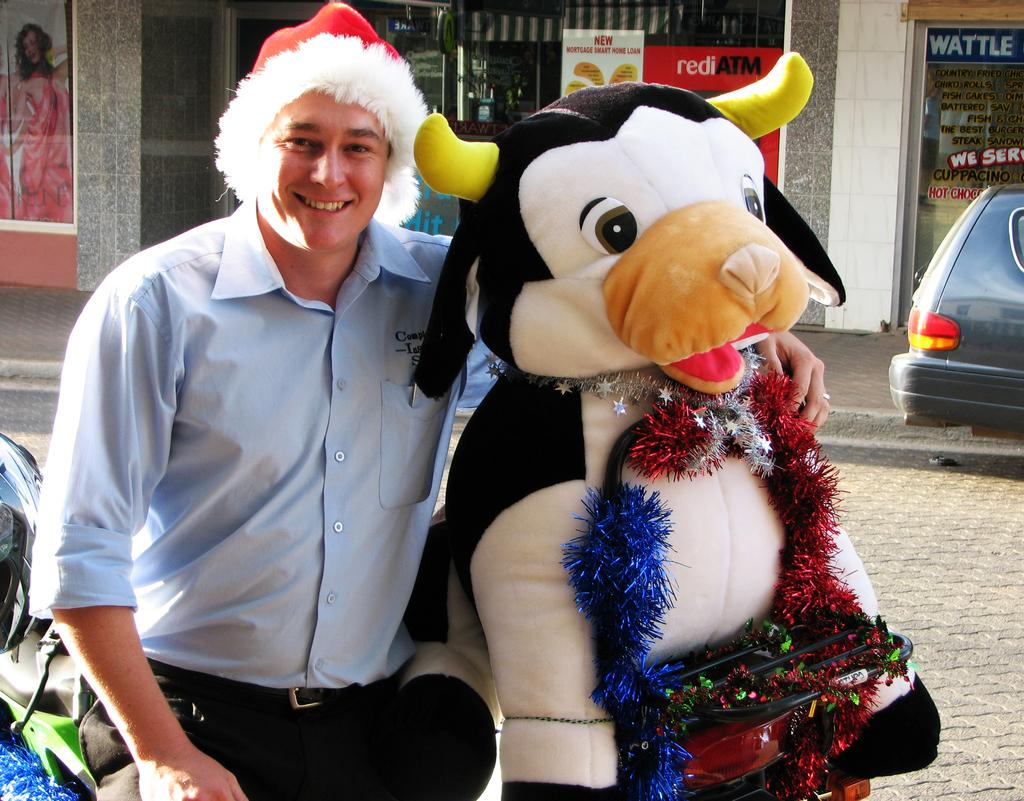Who or what is the main subject in the image? There is a person in the image. What is the person wearing on their head? The person is wearing a red and white color cap. What type of clothing is the person wearing? The person is wearing a different costume. What can be seen in the background of the image? There are stores visible in the background, and there are vehicles on the road. What type of seed is the person planting in the image? There is no seed or planting activity present in the image. Can you tell me the date on the calendar in the image? There is no calendar visible in the image. 